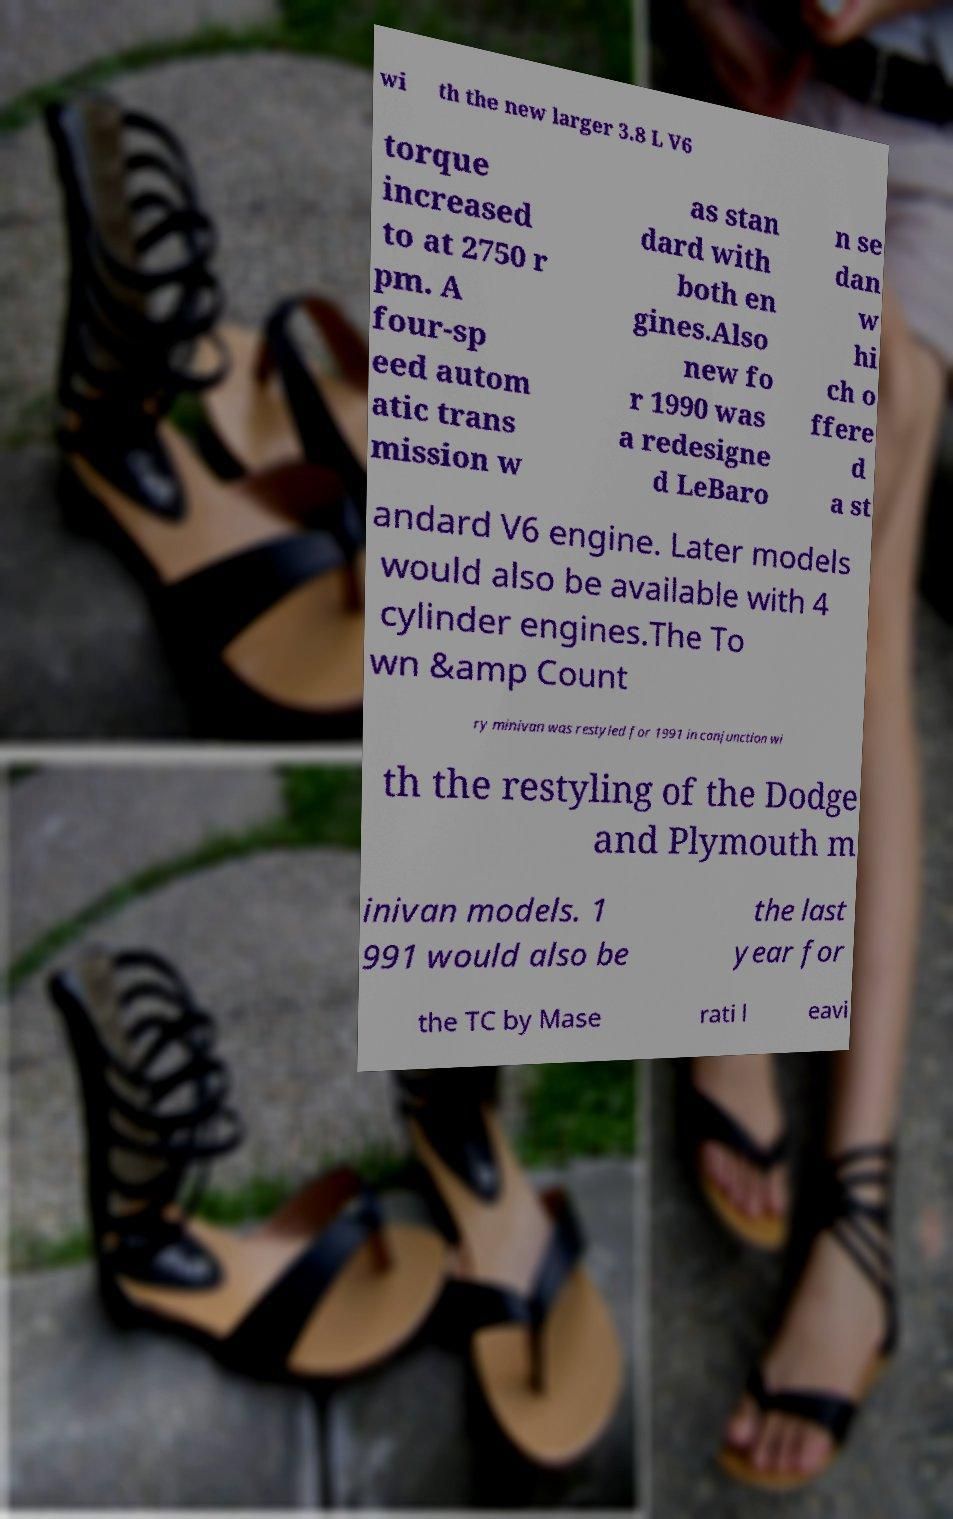I need the written content from this picture converted into text. Can you do that? wi th the new larger 3.8 L V6 torque increased to at 2750 r pm. A four-sp eed autom atic trans mission w as stan dard with both en gines.Also new fo r 1990 was a redesigne d LeBaro n se dan w hi ch o ffere d a st andard V6 engine. Later models would also be available with 4 cylinder engines.The To wn &amp Count ry minivan was restyled for 1991 in conjunction wi th the restyling of the Dodge and Plymouth m inivan models. 1 991 would also be the last year for the TC by Mase rati l eavi 